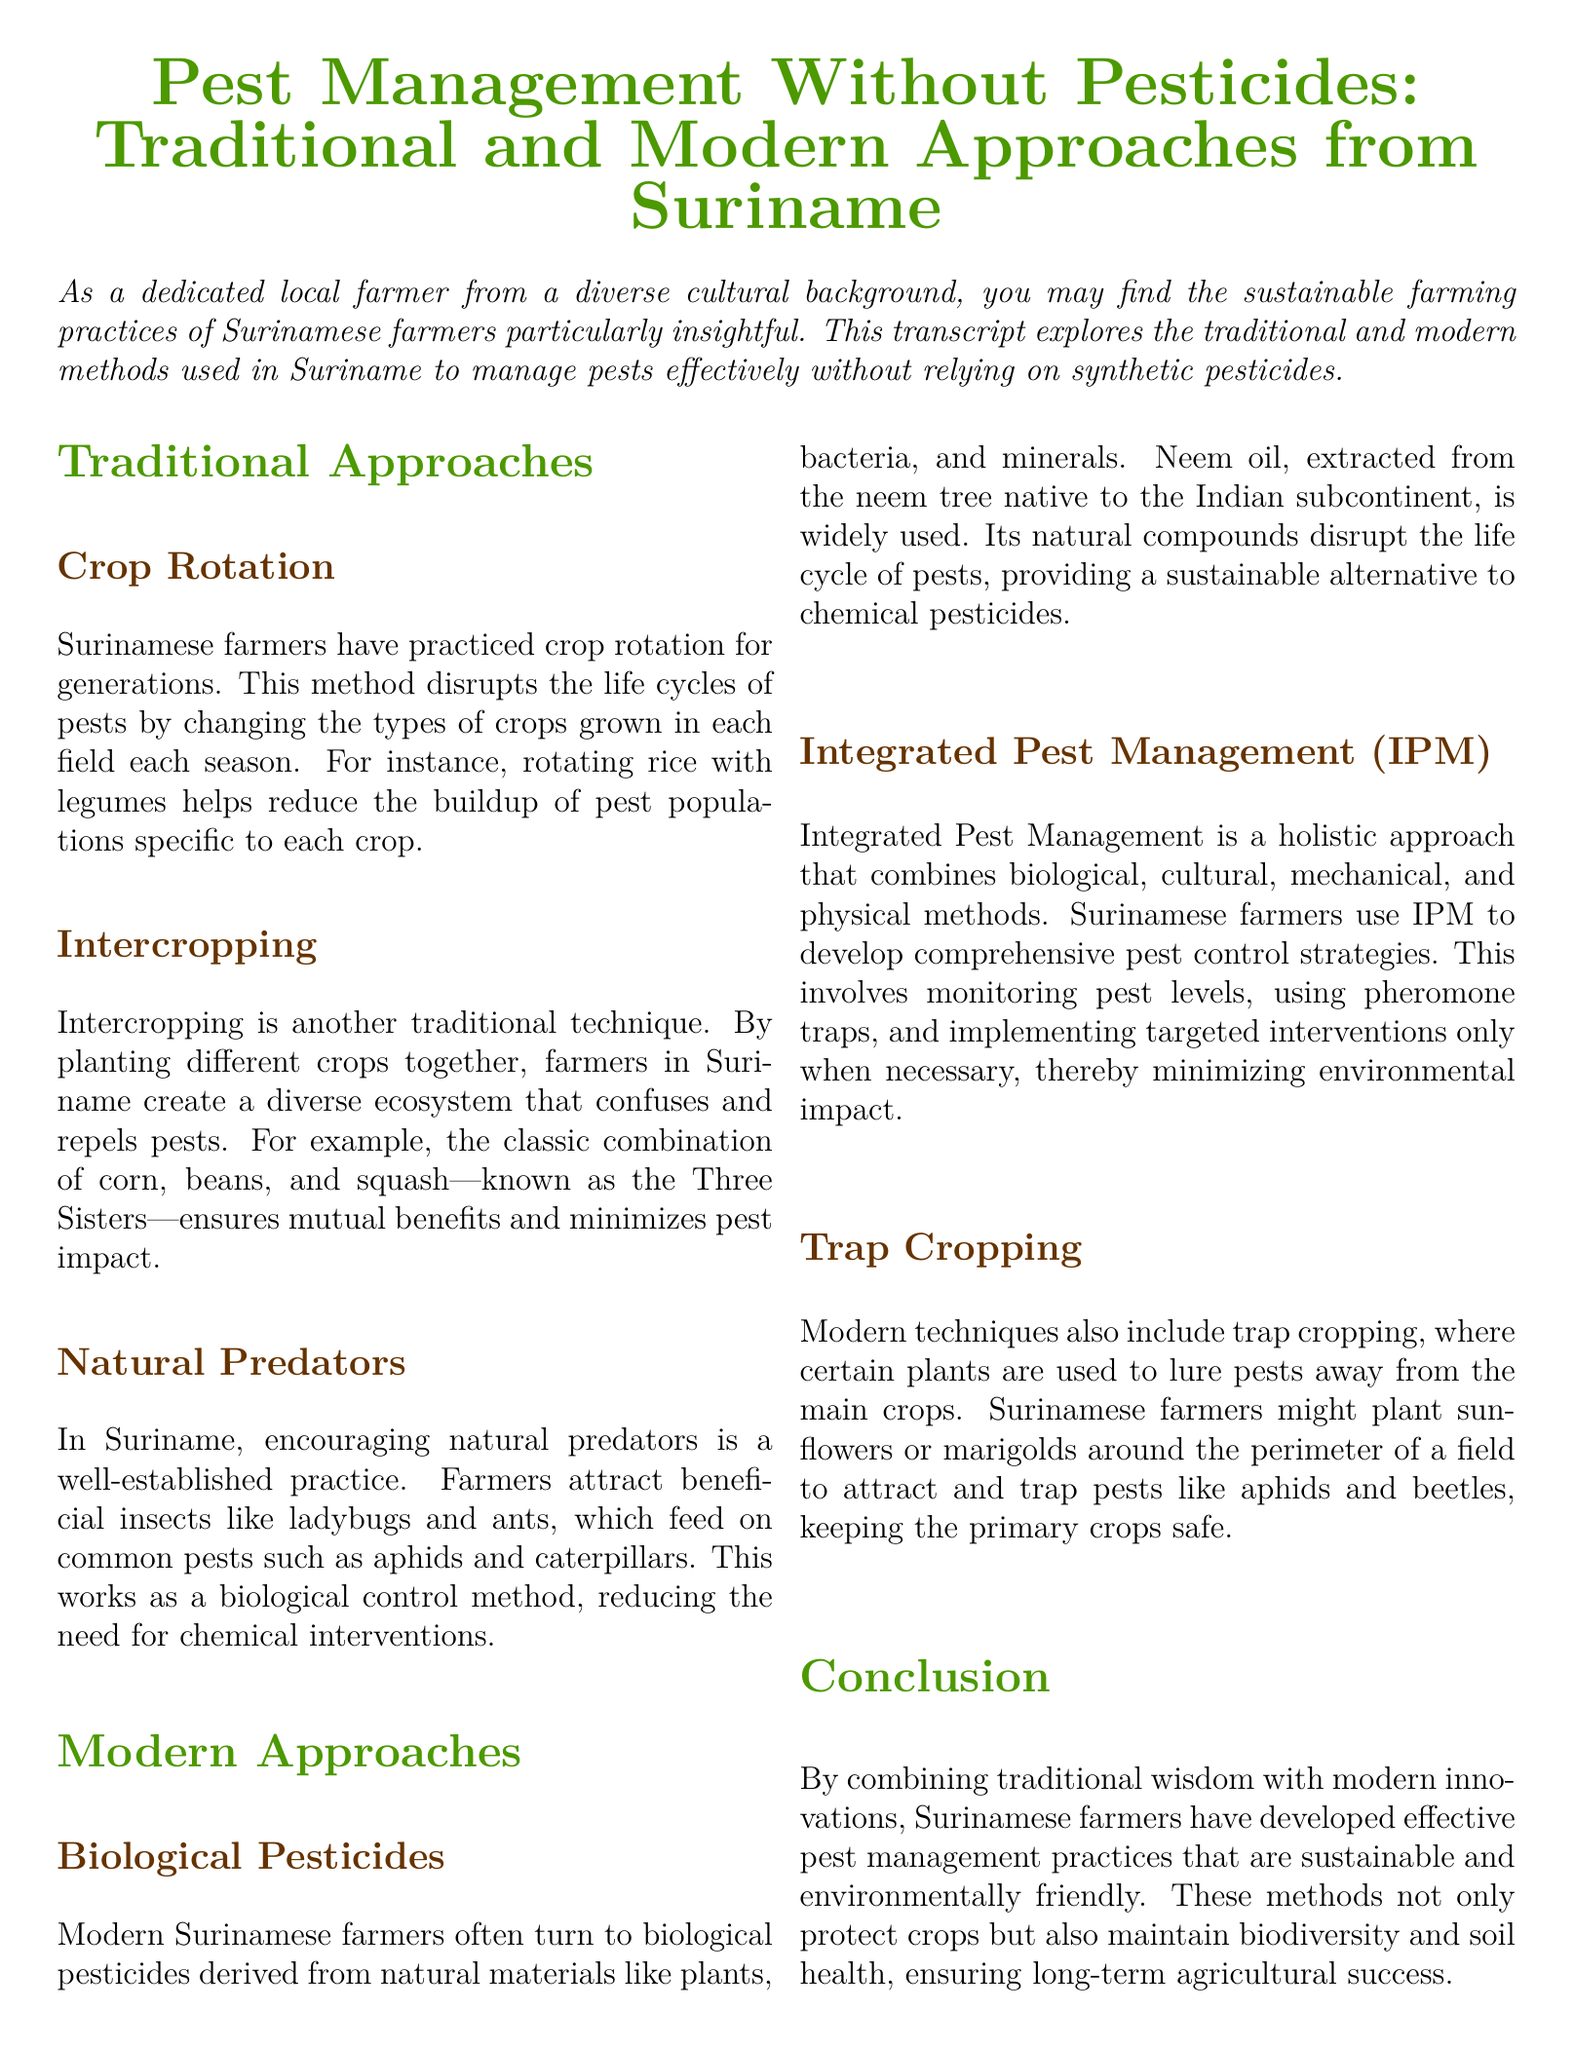What is the focus of the document? The document explores pest management practices without synthetic pesticides in Suriname.
Answer: Pest Management Without Pesticides What traditional method involves changing crops each season? The document mentions crop rotation as a traditional pest management method.
Answer: Crop Rotation What is the purpose of intercropping in Suriname? Intercropping creates a diverse ecosystem that confuses and repels pests.
Answer: Confuses and repels pests What is an example of a biological pesticide used in Suriname? Neem oil is highlighted as a widely used biological pesticide in the document.
Answer: Neem oil What does IPM stand for? The document mentions IPM as an integrated approach to pest management.
Answer: Integrated Pest Management Which combination of crops is referred to as the Three Sisters? Corn, beans, and squash make up the traditional combination known as the Three Sisters.
Answer: Corn, beans, and squash What is the goal of trap cropping? Trap cropping aims to lure pests away from main crops.
Answer: Lure pests away What type of natural predators do Surinamese farmers encourage? Farmers attract beneficial insects like ladybugs and ants as natural predators.
Answer: Ladybugs and ants What is one of the outcomes of sustainable pest management practices? The document concludes that these methods maintain biodiversity and soil health.
Answer: Maintain biodiversity and soil health 